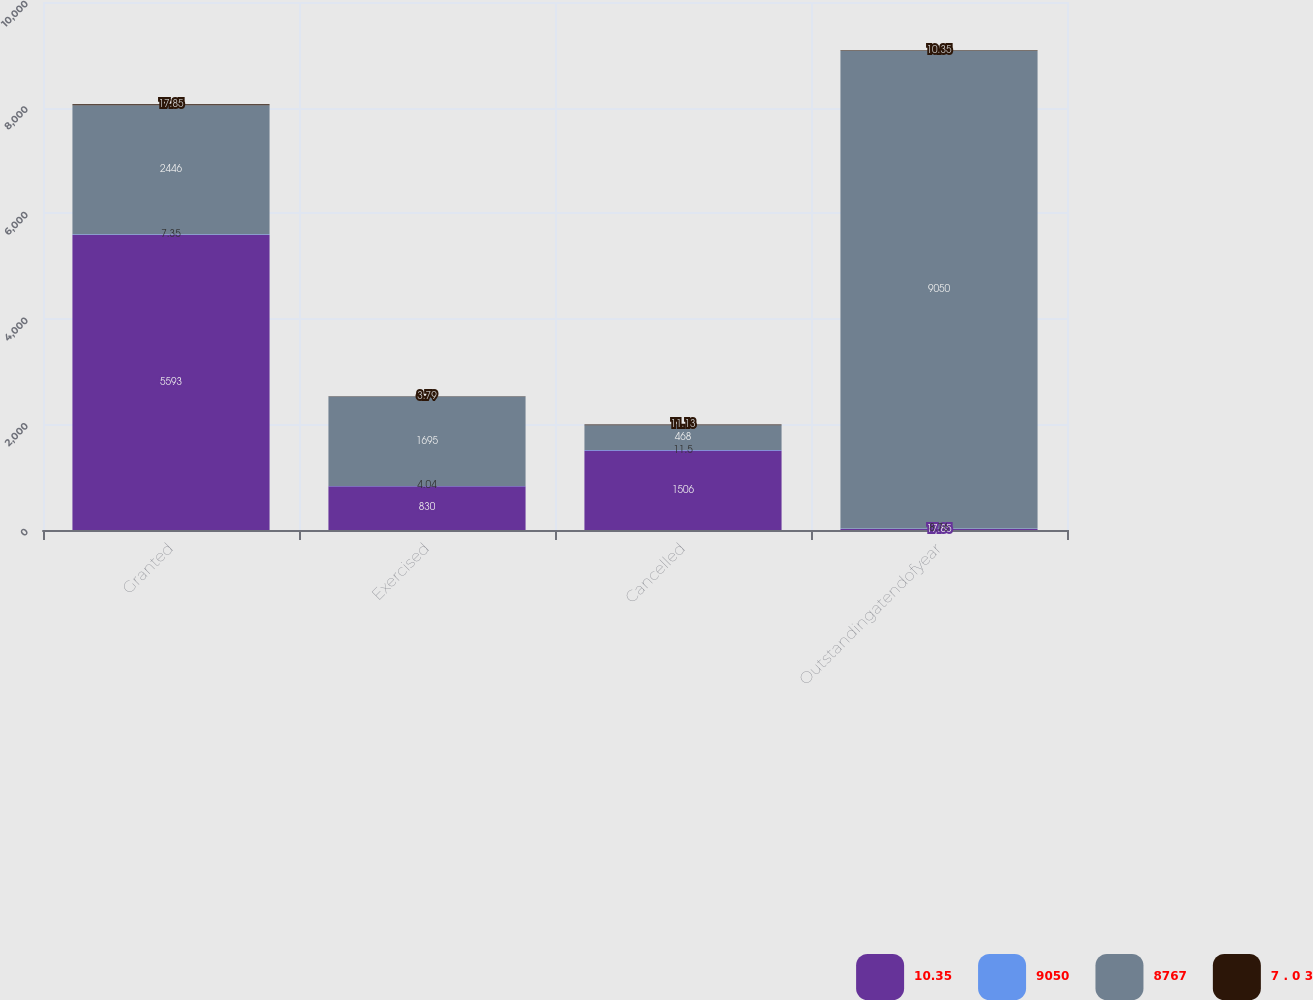Convert chart. <chart><loc_0><loc_0><loc_500><loc_500><stacked_bar_chart><ecel><fcel>Granted<fcel>Exercised<fcel>Cancelled<fcel>Outstandingatendofyear<nl><fcel>10.35<fcel>5593<fcel>830<fcel>1506<fcel>17.85<nl><fcel>9050<fcel>7.35<fcel>4.04<fcel>11.5<fcel>8.76<nl><fcel>8767<fcel>2446<fcel>1695<fcel>468<fcel>9050<nl><fcel>7 . 0 3<fcel>17.85<fcel>3.79<fcel>11.13<fcel>10.35<nl></chart> 